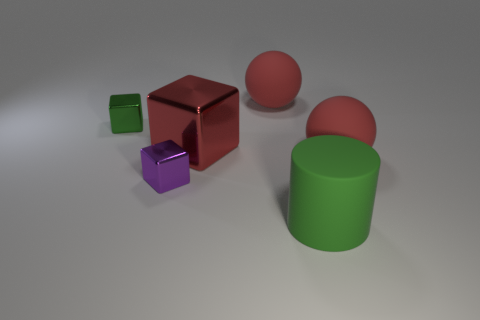How big is the red block?
Make the answer very short. Large. There is a tiny cube in front of the small thing that is left of the small purple object; what number of shiny objects are on the right side of it?
Ensure brevity in your answer.  1. Is the color of the big cylinder the same as the tiny thing to the left of the purple thing?
Your response must be concise. Yes. What number of things are big cylinders to the right of the big red shiny object or green objects to the left of the big red metallic object?
Provide a succinct answer. 2. Is the number of tiny shiny blocks that are on the left side of the small purple object greater than the number of green cylinders behind the green cylinder?
Make the answer very short. Yes. What material is the red sphere that is in front of the large red object behind the tiny metal block behind the purple metallic object?
Make the answer very short. Rubber. There is a red object that is behind the green metal block; is it the same shape as the green object that is behind the big shiny thing?
Keep it short and to the point. No. Are there any shiny blocks that have the same size as the purple metallic thing?
Offer a terse response. Yes. What number of cyan things are large matte balls or large matte objects?
Offer a very short reply. 0. How many big cylinders are the same color as the big metallic object?
Make the answer very short. 0. 